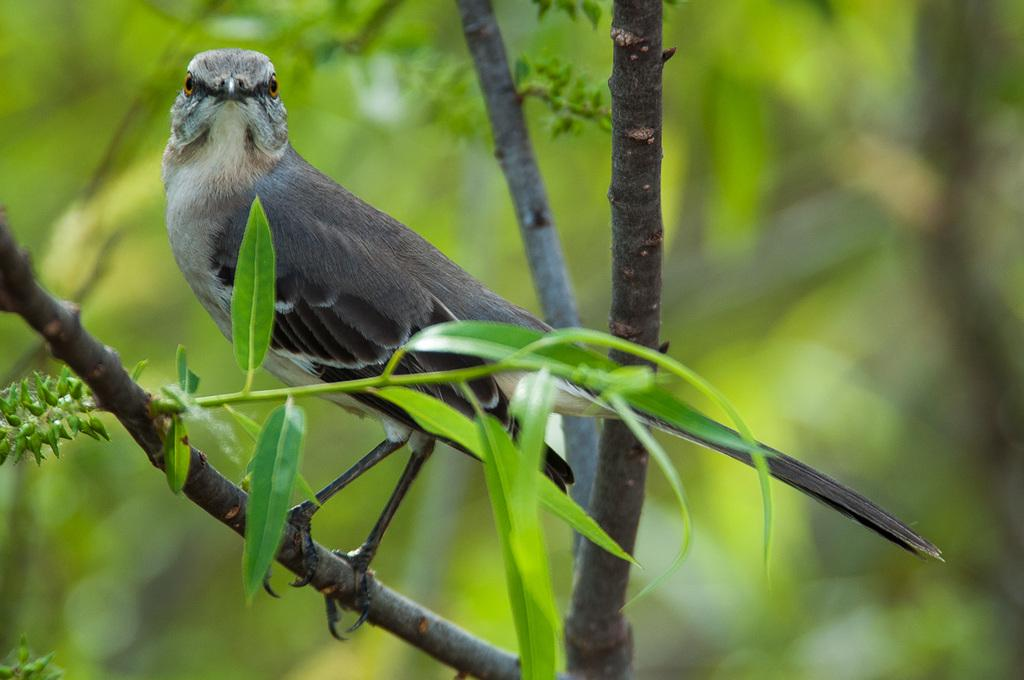What type of animal is in the image? There is a bird in the image. Where is the bird located? The bird is on a stem. What else can be seen in the image besides the bird? There are leaves visible in the image. What is visible in the background of the image? There are trees in the background of the image. How many ducks are sitting on the bun in the image? There are no ducks or buns present in the image; it features a bird on a stem with leaves and trees in the background. 